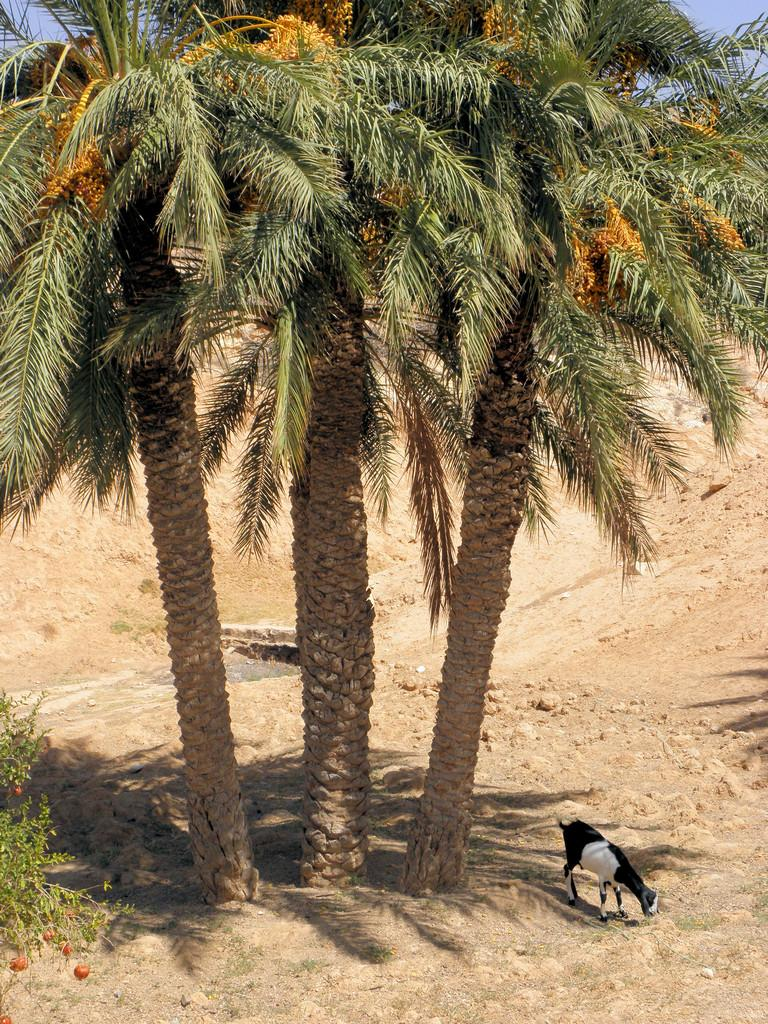What type of vegetation is in the foreground of the image? There are trees in the foreground of the image. Can you describe the tree on the left side of the image? There is a tree on the left side of the image. What type of animal can be seen on the land in the image? There is a goat on the land in the image. What is visible at the top of the image? The sky is visible at the top of the image. What type of wine is being served in the image? There is no wine present in the image; it features trees, a tree, a goat, and the sky. What type of cloth is draped over the goat in the image? There is no cloth present in the image; the goat is not covered or draped with any material. 